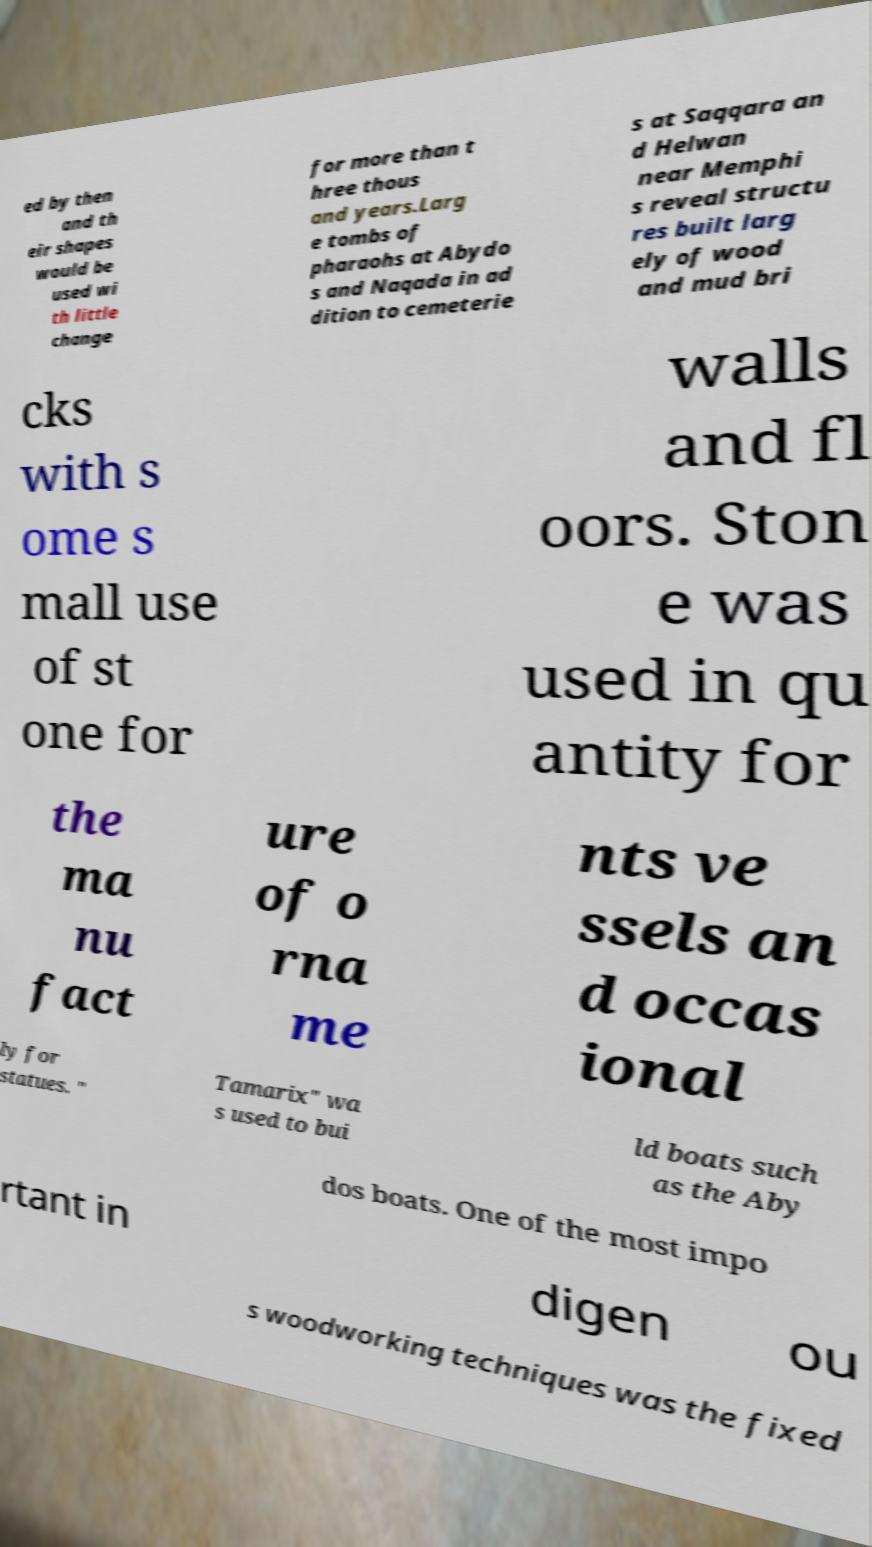Please read and relay the text visible in this image. What does it say? ed by then and th eir shapes would be used wi th little change for more than t hree thous and years.Larg e tombs of pharaohs at Abydo s and Naqada in ad dition to cemeterie s at Saqqara an d Helwan near Memphi s reveal structu res built larg ely of wood and mud bri cks with s ome s mall use of st one for walls and fl oors. Ston e was used in qu antity for the ma nu fact ure of o rna me nts ve ssels an d occas ional ly for statues. " Tamarix" wa s used to bui ld boats such as the Aby dos boats. One of the most impo rtant in digen ou s woodworking techniques was the fixed 